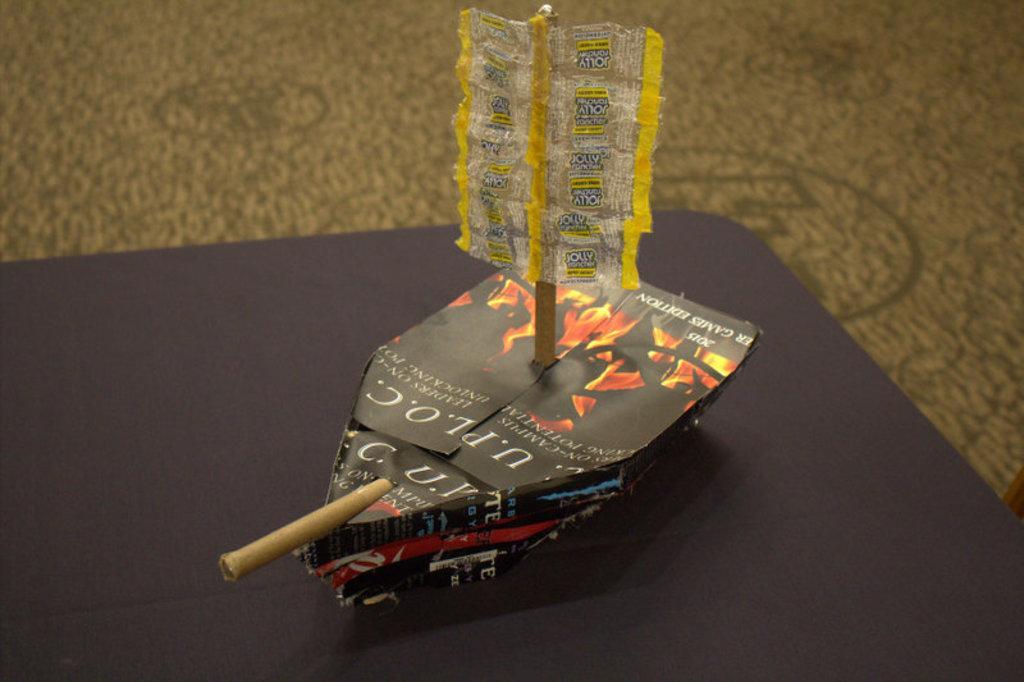How would you summarize this image in a sentence or two? In this image there is a paper boat on the table. 